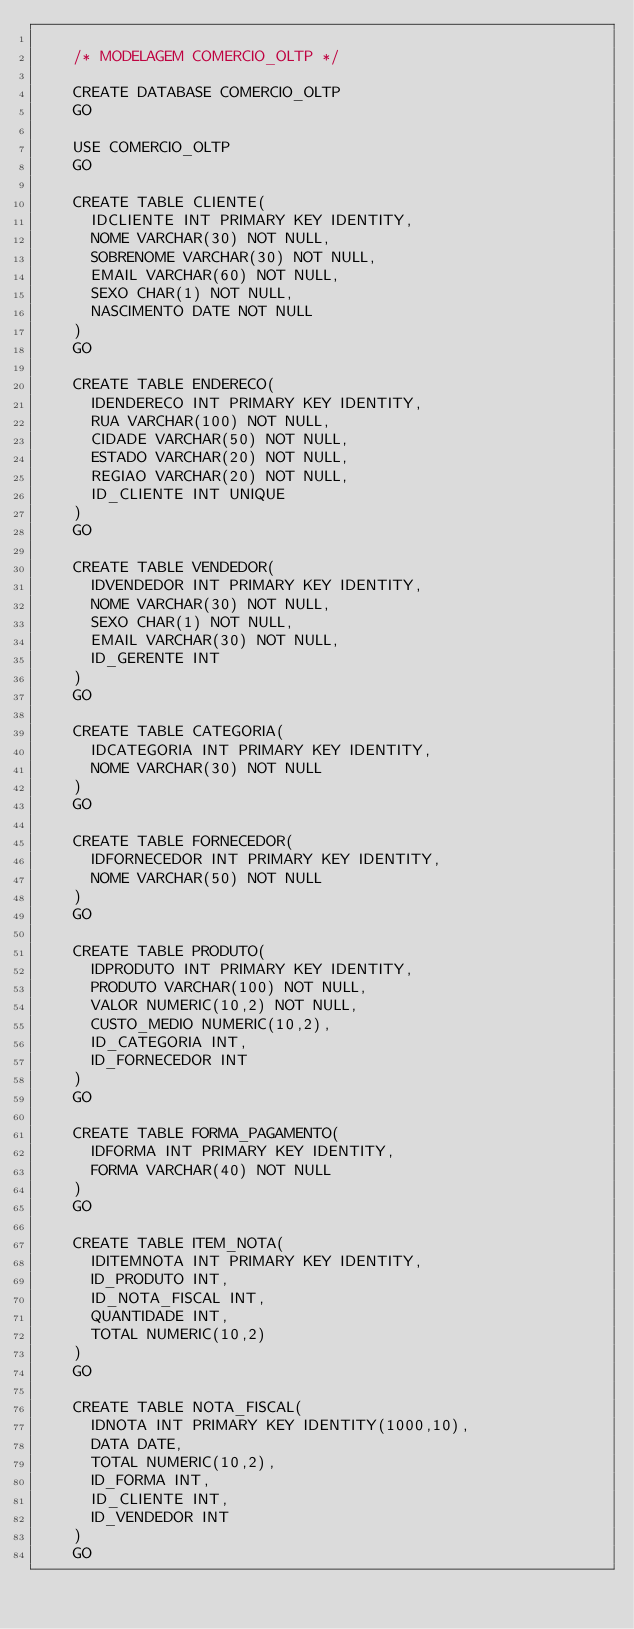Convert code to text. <code><loc_0><loc_0><loc_500><loc_500><_SQL_>		
		/* MODELAGEM COMERCIO_OLTP */

		CREATE DATABASE COMERCIO_OLTP
		GO

		USE COMERCIO_OLTP
		GO

		CREATE TABLE CLIENTE(
			IDCLIENTE INT PRIMARY KEY IDENTITY,
			NOME VARCHAR(30) NOT NULL,
			SOBRENOME VARCHAR(30) NOT NULL,
			EMAIL VARCHAR(60) NOT NULL,
			SEXO CHAR(1) NOT NULL,
			NASCIMENTO DATE NOT NULL
		)	
		GO

		CREATE TABLE ENDERECO(
			IDENDERECO INT PRIMARY KEY IDENTITY,
			RUA VARCHAR(100) NOT NULL,
			CIDADE VARCHAR(50) NOT NULL,
			ESTADO VARCHAR(20) NOT NULL,
			REGIAO VARCHAR(20) NOT NULL,
			ID_CLIENTE INT UNIQUE
		)
		GO

		CREATE TABLE VENDEDOR(
			IDVENDEDOR INT PRIMARY KEY IDENTITY,
			NOME VARCHAR(30) NOT NULL,
			SEXO CHAR(1) NOT NULL,
			EMAIL VARCHAR(30) NOT NULL,
			ID_GERENTE INT
		)
		GO

		CREATE TABLE CATEGORIA(
			IDCATEGORIA INT PRIMARY KEY IDENTITY,
			NOME VARCHAR(30) NOT NULL
		)
		GO

		CREATE TABLE FORNECEDOR(
			IDFORNECEDOR INT PRIMARY KEY IDENTITY,
			NOME VARCHAR(50) NOT NULL
		)
		GO

		CREATE TABLE PRODUTO(
			IDPRODUTO INT PRIMARY KEY IDENTITY,
			PRODUTO VARCHAR(100) NOT NULL,
			VALOR NUMERIC(10,2) NOT NULL,
			CUSTO_MEDIO NUMERIC(10,2),
			ID_CATEGORIA INT,
			ID_FORNECEDOR INT
		)
		GO

		CREATE TABLE FORMA_PAGAMENTO(
			IDFORMA INT PRIMARY KEY IDENTITY,
			FORMA VARCHAR(40) NOT NULL
		)
		GO

		CREATE TABLE ITEM_NOTA(
			IDITEMNOTA INT PRIMARY KEY IDENTITY,
			ID_PRODUTO INT,
			ID_NOTA_FISCAL INT,
			QUANTIDADE INT,
			TOTAL NUMERIC(10,2)	
		)
		GO

		CREATE TABLE NOTA_FISCAL(
			IDNOTA INT PRIMARY KEY IDENTITY(1000,10),
			DATA DATE,
			TOTAL NUMERIC(10,2),
			ID_FORMA INT,
			ID_CLIENTE INT,
			ID_VENDEDOR INT
		)
		GO

</code> 